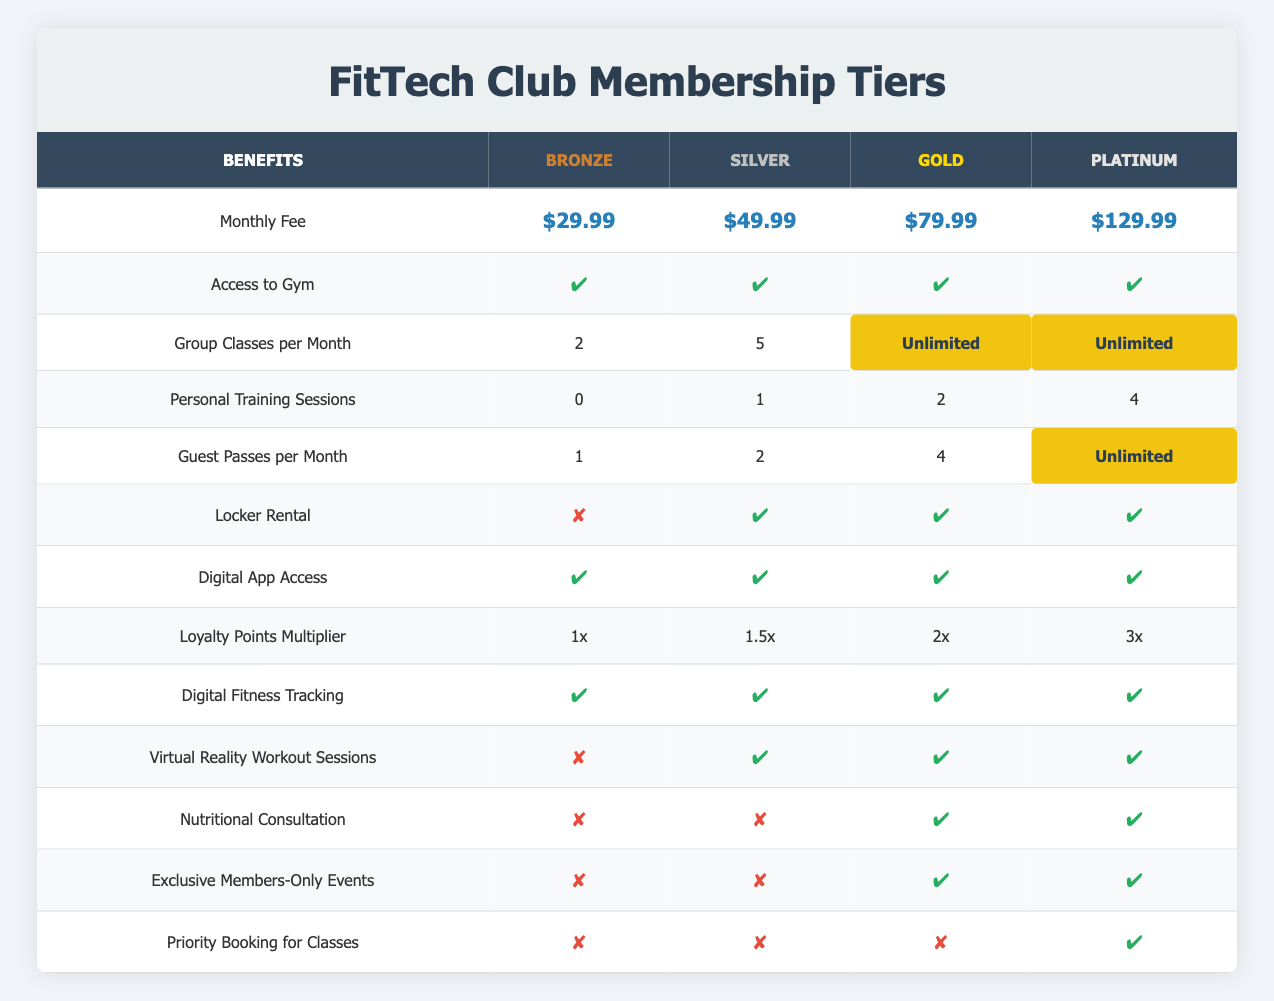What is the monthly fee for the Gold membership tier? The monthly fee for the Gold membership tier is clearly stated in the table under the "Monthly Fee" row and the Gold column, which shows $79.99.
Answer: $79.99 How many group classes per month are offered in the Silver tier? The Silver membership tier allows 5 group classes per month, as shown in the corresponding row and column for Silver in the "Group Classes per Month" section.
Answer: 5 Is locker rental included in the Bronze membership? The table indicates that locker rental is marked with a cross (✘) in the Bronze row, confirming that it is not included in that membership tier.
Answer: No Which membership tier offers nutritional consultation? Referring to the "Nutritional Consultation" row, the Gold and Platinum tiers both have a check mark (✔), meaning they offer this benefit, while Bronze and Silver do not.
Answer: Gold and Platinum What is the total number of guest passes provided for both Gold and Platinum tiers combined? The Gold tier offers 4 guest passes, and the Platinum tier offers unlimited guest passes. For simplicity of this calculation, we will consider unlimited as a large number, effectively meaning you can invite as many guests as desired. Thus the total becomes 4 + unlimited, which can be interpreted as unlimited.
Answer: Unlimited Which tier has the highest loyalty points multiplier? Looking at the "Loyalty Points Multiplier" row, the Platinum tier has the highest multiplier of 3x, as seen in the corresponding column.
Answer: 3x Do all membership tiers provide access to digital fitness tracking? By checking the "Digital Fitness Tracking" row, all tiers (Bronze, Silver, Gold, and Platinum) have a check mark (✔), demonstrating that this benefit is available across all tiers.
Answer: Yes In terms of personal training sessions, how much more does the Platinum tier offer compared to the Bronze tier? The Platinum tier provides 4 personal training sessions while the Bronze tier provides none. To find the difference, subtract Bronze (0) from Platinum (4), resulting in 4 more sessions offered in the Platinum tier.
Answer: 4 sessions Which tiers have priority booking for classes? The "Priority Booking for Classes" row shows that only the Platinum tier is marked with a check (✔), while the other tiers (Bronze, Silver, Gold) have a cross (✘), indicating they do not have this benefit.
Answer: Platinum 